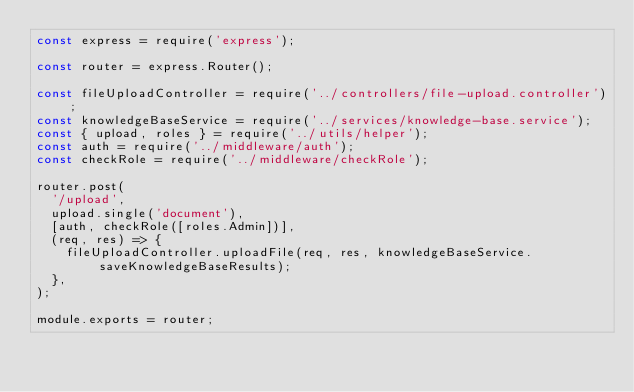Convert code to text. <code><loc_0><loc_0><loc_500><loc_500><_JavaScript_>const express = require('express');

const router = express.Router();

const fileUploadController = require('../controllers/file-upload.controller');
const knowledgeBaseService = require('../services/knowledge-base.service');
const { upload, roles } = require('../utils/helper');
const auth = require('../middleware/auth');
const checkRole = require('../middleware/checkRole');

router.post(
  '/upload',
  upload.single('document'),
  [auth, checkRole([roles.Admin])],
  (req, res) => {
    fileUploadController.uploadFile(req, res, knowledgeBaseService.saveKnowledgeBaseResults);
  },
);

module.exports = router;
</code> 